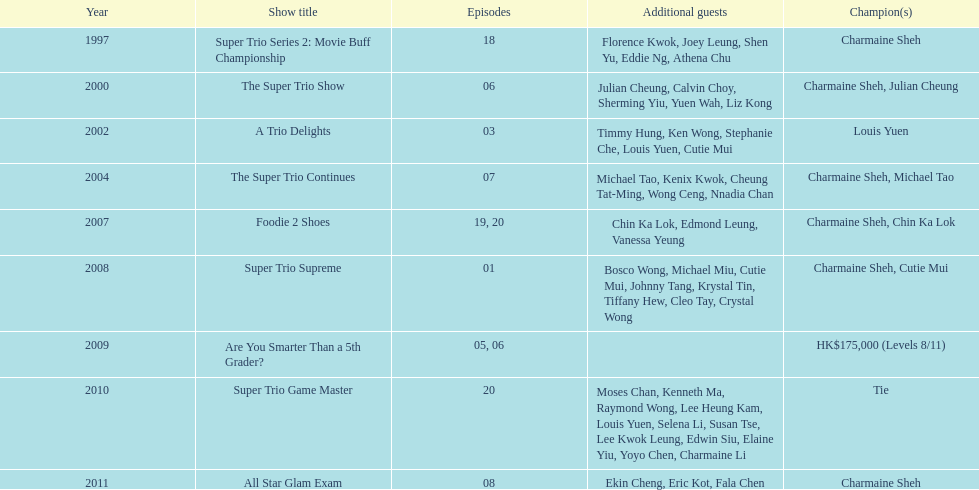What was the total number of trio series shows were charmaine sheh on? 6. Would you mind parsing the complete table? {'header': ['Year', 'Show title', 'Episodes', 'Additional guests', 'Champion(s)'], 'rows': [['1997', 'Super Trio Series 2: Movie Buff Championship', '18', 'Florence Kwok, Joey Leung, Shen Yu, Eddie Ng, Athena Chu', 'Charmaine Sheh'], ['2000', 'The Super Trio Show', '06', 'Julian Cheung, Calvin Choy, Sherming Yiu, Yuen Wah, Liz Kong', 'Charmaine Sheh, Julian Cheung'], ['2002', 'A Trio Delights', '03', 'Timmy Hung, Ken Wong, Stephanie Che, Louis Yuen, Cutie Mui', 'Louis Yuen'], ['2004', 'The Super Trio Continues', '07', 'Michael Tao, Kenix Kwok, Cheung Tat-Ming, Wong Ceng, Nnadia Chan', 'Charmaine Sheh, Michael Tao'], ['2007', 'Foodie 2 Shoes', '19, 20', 'Chin Ka Lok, Edmond Leung, Vanessa Yeung', 'Charmaine Sheh, Chin Ka Lok'], ['2008', 'Super Trio Supreme', '01', 'Bosco Wong, Michael Miu, Cutie Mui, Johnny Tang, Krystal Tin, Tiffany Hew, Cleo Tay, Crystal Wong', 'Charmaine Sheh, Cutie Mui'], ['2009', 'Are You Smarter Than a 5th Grader?', '05, 06', '', 'HK$175,000 (Levels 8/11)'], ['2010', 'Super Trio Game Master', '20', 'Moses Chan, Kenneth Ma, Raymond Wong, Lee Heung Kam, Louis Yuen, Selena Li, Susan Tse, Lee Kwok Leung, Edwin Siu, Elaine Yiu, Yoyo Chen, Charmaine Li', 'Tie'], ['2011', 'All Star Glam Exam', '08', 'Ekin Cheng, Eric Kot, Fala Chen', 'Charmaine Sheh']]} 